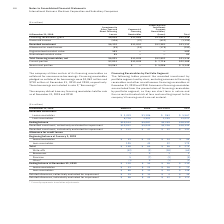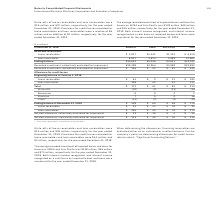According to International Business Machines's financial document, Why are Commercial financing receivables are excluded from financing receivables? they are short term in nature and the current estimated risk of loss and resulting impact to the company’s financing results are not material.. The document states: "of financing receivables by portfolio segment, as they are short term in nature and the current estimated risk of loss and resulting impact to the com..." Also, What were the write-offs in December 2019? According to the financial document, $16 million. The relevant text states: "ffs of lease receivables and loan receivables were $16 million and $47 million, respectively, for the year ended December 31, 2019. Provisions for credit losses re..." Also, What is the average recorded investment of impaired leases and loans for Americas for December 2019? According to the financial document, $138 million. The relevant text states: "and loans for Americas, EMEA and Asia Pacific was $138 million, $49 million and $45 million, respectively, for the year ended December 31, 2019. Both interest inc..." Also, can you calculate: What is the average Recorded investment of Lease receivables for Americas and EMEA for December 2019? To answer this question, I need to perform calculations using the financial data. The calculation is: (3,419+1,186) / 2 , which equals 2302.5 (in millions). This is based on the information: "Lease receivables $ 3,419 $1,186 $ 963 $ 5,567 Lease receivables $ 3,419 $1,186 $ 963 $ 5,567..." The key data points involved are: 1,186, 3,419. Also, can you calculate: What is the average Recorded investment of Loan receivables for Americas and EMEA for December 2019? To answer this question, I need to perform calculations using the financial data. The calculation is: (6,726+3,901) / 2 , which equals 5313.5 (in millions). This is based on the information: "Loan receivables 6,726 3,901 2,395 13,022 Loan receivables 6,726 3,901 2,395 13,022..." The key data points involved are: 3,901, 6,726. Also, can you calculate: What is the average Allowance for credit losses of Lease receivables at the beginning of January 2019? Based on the calculation: 99/ 3, the result is 33 (in millions). This is based on the information: "ectively evaluated for impairment $10,032 $5,040 $3,326 $18,399 aluated for impairment $10,032 $5,040 $3,326 $18,399..." The key data points involved are: 99. 